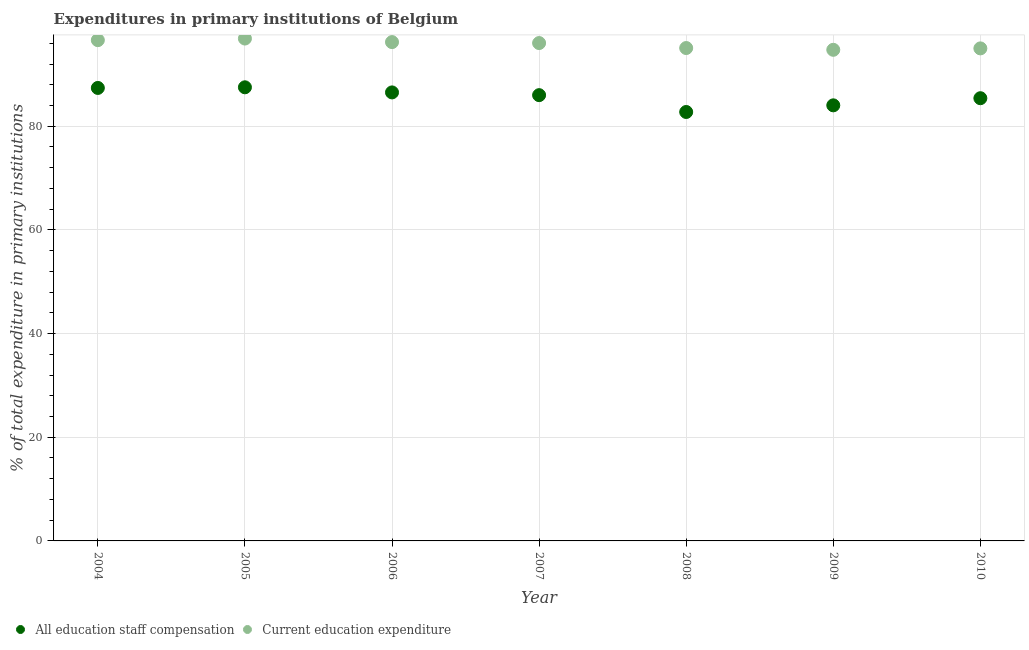How many different coloured dotlines are there?
Your response must be concise. 2. Is the number of dotlines equal to the number of legend labels?
Your response must be concise. Yes. What is the expenditure in education in 2009?
Give a very brief answer. 94.74. Across all years, what is the maximum expenditure in staff compensation?
Provide a short and direct response. 87.51. Across all years, what is the minimum expenditure in education?
Give a very brief answer. 94.74. In which year was the expenditure in staff compensation maximum?
Ensure brevity in your answer.  2005. What is the total expenditure in education in the graph?
Your answer should be very brief. 670.62. What is the difference between the expenditure in education in 2005 and that in 2007?
Provide a short and direct response. 0.87. What is the difference between the expenditure in staff compensation in 2004 and the expenditure in education in 2008?
Provide a succinct answer. -7.7. What is the average expenditure in education per year?
Your answer should be compact. 95.8. In the year 2008, what is the difference between the expenditure in staff compensation and expenditure in education?
Your answer should be very brief. -12.34. In how many years, is the expenditure in staff compensation greater than 84 %?
Make the answer very short. 6. What is the ratio of the expenditure in education in 2006 to that in 2007?
Your answer should be compact. 1. Is the expenditure in staff compensation in 2005 less than that in 2006?
Keep it short and to the point. No. Is the difference between the expenditure in education in 2006 and 2008 greater than the difference between the expenditure in staff compensation in 2006 and 2008?
Provide a succinct answer. No. What is the difference between the highest and the second highest expenditure in staff compensation?
Provide a short and direct response. 0.12. What is the difference between the highest and the lowest expenditure in education?
Ensure brevity in your answer.  2.17. In how many years, is the expenditure in education greater than the average expenditure in education taken over all years?
Provide a succinct answer. 4. Does the expenditure in staff compensation monotonically increase over the years?
Your answer should be very brief. No. Is the expenditure in staff compensation strictly greater than the expenditure in education over the years?
Make the answer very short. No. Are the values on the major ticks of Y-axis written in scientific E-notation?
Your answer should be compact. No. Does the graph contain grids?
Offer a terse response. Yes. Where does the legend appear in the graph?
Your answer should be compact. Bottom left. How many legend labels are there?
Provide a succinct answer. 2. How are the legend labels stacked?
Provide a short and direct response. Horizontal. What is the title of the graph?
Provide a succinct answer. Expenditures in primary institutions of Belgium. What is the label or title of the X-axis?
Provide a succinct answer. Year. What is the label or title of the Y-axis?
Give a very brief answer. % of total expenditure in primary institutions. What is the % of total expenditure in primary institutions of All education staff compensation in 2004?
Keep it short and to the point. 87.38. What is the % of total expenditure in primary institutions of Current education expenditure in 2004?
Your answer should be very brief. 96.6. What is the % of total expenditure in primary institutions in All education staff compensation in 2005?
Give a very brief answer. 87.51. What is the % of total expenditure in primary institutions in Current education expenditure in 2005?
Keep it short and to the point. 96.91. What is the % of total expenditure in primary institutions of All education staff compensation in 2006?
Keep it short and to the point. 86.52. What is the % of total expenditure in primary institutions in Current education expenditure in 2006?
Provide a succinct answer. 96.23. What is the % of total expenditure in primary institutions of All education staff compensation in 2007?
Provide a short and direct response. 85.99. What is the % of total expenditure in primary institutions in Current education expenditure in 2007?
Provide a succinct answer. 96.04. What is the % of total expenditure in primary institutions in All education staff compensation in 2008?
Keep it short and to the point. 82.74. What is the % of total expenditure in primary institutions of Current education expenditure in 2008?
Keep it short and to the point. 95.08. What is the % of total expenditure in primary institutions of All education staff compensation in 2009?
Offer a very short reply. 84.03. What is the % of total expenditure in primary institutions of Current education expenditure in 2009?
Your answer should be compact. 94.74. What is the % of total expenditure in primary institutions of All education staff compensation in 2010?
Give a very brief answer. 85.4. What is the % of total expenditure in primary institutions of Current education expenditure in 2010?
Make the answer very short. 95.01. Across all years, what is the maximum % of total expenditure in primary institutions of All education staff compensation?
Provide a succinct answer. 87.51. Across all years, what is the maximum % of total expenditure in primary institutions of Current education expenditure?
Provide a succinct answer. 96.91. Across all years, what is the minimum % of total expenditure in primary institutions of All education staff compensation?
Your answer should be very brief. 82.74. Across all years, what is the minimum % of total expenditure in primary institutions of Current education expenditure?
Your response must be concise. 94.74. What is the total % of total expenditure in primary institutions of All education staff compensation in the graph?
Provide a short and direct response. 599.58. What is the total % of total expenditure in primary institutions of Current education expenditure in the graph?
Your answer should be compact. 670.62. What is the difference between the % of total expenditure in primary institutions of All education staff compensation in 2004 and that in 2005?
Make the answer very short. -0.12. What is the difference between the % of total expenditure in primary institutions of Current education expenditure in 2004 and that in 2005?
Your answer should be very brief. -0.31. What is the difference between the % of total expenditure in primary institutions in All education staff compensation in 2004 and that in 2006?
Your answer should be very brief. 0.86. What is the difference between the % of total expenditure in primary institutions of Current education expenditure in 2004 and that in 2006?
Your response must be concise. 0.38. What is the difference between the % of total expenditure in primary institutions of All education staff compensation in 2004 and that in 2007?
Ensure brevity in your answer.  1.39. What is the difference between the % of total expenditure in primary institutions of Current education expenditure in 2004 and that in 2007?
Keep it short and to the point. 0.56. What is the difference between the % of total expenditure in primary institutions in All education staff compensation in 2004 and that in 2008?
Your answer should be very brief. 4.64. What is the difference between the % of total expenditure in primary institutions in Current education expenditure in 2004 and that in 2008?
Your response must be concise. 1.52. What is the difference between the % of total expenditure in primary institutions of All education staff compensation in 2004 and that in 2009?
Your response must be concise. 3.36. What is the difference between the % of total expenditure in primary institutions of Current education expenditure in 2004 and that in 2009?
Offer a terse response. 1.86. What is the difference between the % of total expenditure in primary institutions of All education staff compensation in 2004 and that in 2010?
Provide a succinct answer. 1.98. What is the difference between the % of total expenditure in primary institutions of Current education expenditure in 2004 and that in 2010?
Make the answer very short. 1.59. What is the difference between the % of total expenditure in primary institutions of All education staff compensation in 2005 and that in 2006?
Give a very brief answer. 0.99. What is the difference between the % of total expenditure in primary institutions of Current education expenditure in 2005 and that in 2006?
Your answer should be compact. 0.68. What is the difference between the % of total expenditure in primary institutions in All education staff compensation in 2005 and that in 2007?
Make the answer very short. 1.51. What is the difference between the % of total expenditure in primary institutions of Current education expenditure in 2005 and that in 2007?
Your response must be concise. 0.87. What is the difference between the % of total expenditure in primary institutions in All education staff compensation in 2005 and that in 2008?
Keep it short and to the point. 4.76. What is the difference between the % of total expenditure in primary institutions in Current education expenditure in 2005 and that in 2008?
Offer a very short reply. 1.83. What is the difference between the % of total expenditure in primary institutions in All education staff compensation in 2005 and that in 2009?
Make the answer very short. 3.48. What is the difference between the % of total expenditure in primary institutions in Current education expenditure in 2005 and that in 2009?
Provide a succinct answer. 2.17. What is the difference between the % of total expenditure in primary institutions of All education staff compensation in 2005 and that in 2010?
Offer a very short reply. 2.1. What is the difference between the % of total expenditure in primary institutions of Current education expenditure in 2005 and that in 2010?
Ensure brevity in your answer.  1.9. What is the difference between the % of total expenditure in primary institutions in All education staff compensation in 2006 and that in 2007?
Your answer should be very brief. 0.53. What is the difference between the % of total expenditure in primary institutions in Current education expenditure in 2006 and that in 2007?
Provide a succinct answer. 0.19. What is the difference between the % of total expenditure in primary institutions of All education staff compensation in 2006 and that in 2008?
Your answer should be very brief. 3.78. What is the difference between the % of total expenditure in primary institutions of Current education expenditure in 2006 and that in 2008?
Make the answer very short. 1.15. What is the difference between the % of total expenditure in primary institutions of All education staff compensation in 2006 and that in 2009?
Your answer should be very brief. 2.5. What is the difference between the % of total expenditure in primary institutions of Current education expenditure in 2006 and that in 2009?
Provide a short and direct response. 1.49. What is the difference between the % of total expenditure in primary institutions of All education staff compensation in 2006 and that in 2010?
Offer a very short reply. 1.12. What is the difference between the % of total expenditure in primary institutions in Current education expenditure in 2006 and that in 2010?
Keep it short and to the point. 1.21. What is the difference between the % of total expenditure in primary institutions of All education staff compensation in 2007 and that in 2008?
Keep it short and to the point. 3.25. What is the difference between the % of total expenditure in primary institutions of Current education expenditure in 2007 and that in 2008?
Your answer should be compact. 0.96. What is the difference between the % of total expenditure in primary institutions of All education staff compensation in 2007 and that in 2009?
Your answer should be compact. 1.97. What is the difference between the % of total expenditure in primary institutions of Current education expenditure in 2007 and that in 2009?
Give a very brief answer. 1.3. What is the difference between the % of total expenditure in primary institutions in All education staff compensation in 2007 and that in 2010?
Provide a short and direct response. 0.59. What is the difference between the % of total expenditure in primary institutions of Current education expenditure in 2007 and that in 2010?
Ensure brevity in your answer.  1.03. What is the difference between the % of total expenditure in primary institutions of All education staff compensation in 2008 and that in 2009?
Ensure brevity in your answer.  -1.28. What is the difference between the % of total expenditure in primary institutions in Current education expenditure in 2008 and that in 2009?
Your answer should be compact. 0.34. What is the difference between the % of total expenditure in primary institutions in All education staff compensation in 2008 and that in 2010?
Give a very brief answer. -2.66. What is the difference between the % of total expenditure in primary institutions of Current education expenditure in 2008 and that in 2010?
Give a very brief answer. 0.07. What is the difference between the % of total expenditure in primary institutions in All education staff compensation in 2009 and that in 2010?
Your answer should be very brief. -1.38. What is the difference between the % of total expenditure in primary institutions in Current education expenditure in 2009 and that in 2010?
Provide a short and direct response. -0.27. What is the difference between the % of total expenditure in primary institutions in All education staff compensation in 2004 and the % of total expenditure in primary institutions in Current education expenditure in 2005?
Ensure brevity in your answer.  -9.53. What is the difference between the % of total expenditure in primary institutions of All education staff compensation in 2004 and the % of total expenditure in primary institutions of Current education expenditure in 2006?
Your answer should be compact. -8.84. What is the difference between the % of total expenditure in primary institutions in All education staff compensation in 2004 and the % of total expenditure in primary institutions in Current education expenditure in 2007?
Your answer should be very brief. -8.66. What is the difference between the % of total expenditure in primary institutions in All education staff compensation in 2004 and the % of total expenditure in primary institutions in Current education expenditure in 2008?
Give a very brief answer. -7.7. What is the difference between the % of total expenditure in primary institutions of All education staff compensation in 2004 and the % of total expenditure in primary institutions of Current education expenditure in 2009?
Provide a short and direct response. -7.36. What is the difference between the % of total expenditure in primary institutions of All education staff compensation in 2004 and the % of total expenditure in primary institutions of Current education expenditure in 2010?
Your response must be concise. -7.63. What is the difference between the % of total expenditure in primary institutions in All education staff compensation in 2005 and the % of total expenditure in primary institutions in Current education expenditure in 2006?
Provide a succinct answer. -8.72. What is the difference between the % of total expenditure in primary institutions of All education staff compensation in 2005 and the % of total expenditure in primary institutions of Current education expenditure in 2007?
Offer a terse response. -8.53. What is the difference between the % of total expenditure in primary institutions in All education staff compensation in 2005 and the % of total expenditure in primary institutions in Current education expenditure in 2008?
Your response must be concise. -7.57. What is the difference between the % of total expenditure in primary institutions of All education staff compensation in 2005 and the % of total expenditure in primary institutions of Current education expenditure in 2009?
Make the answer very short. -7.23. What is the difference between the % of total expenditure in primary institutions of All education staff compensation in 2005 and the % of total expenditure in primary institutions of Current education expenditure in 2010?
Keep it short and to the point. -7.51. What is the difference between the % of total expenditure in primary institutions of All education staff compensation in 2006 and the % of total expenditure in primary institutions of Current education expenditure in 2007?
Ensure brevity in your answer.  -9.52. What is the difference between the % of total expenditure in primary institutions of All education staff compensation in 2006 and the % of total expenditure in primary institutions of Current education expenditure in 2008?
Offer a very short reply. -8.56. What is the difference between the % of total expenditure in primary institutions in All education staff compensation in 2006 and the % of total expenditure in primary institutions in Current education expenditure in 2009?
Your answer should be very brief. -8.22. What is the difference between the % of total expenditure in primary institutions of All education staff compensation in 2006 and the % of total expenditure in primary institutions of Current education expenditure in 2010?
Ensure brevity in your answer.  -8.49. What is the difference between the % of total expenditure in primary institutions in All education staff compensation in 2007 and the % of total expenditure in primary institutions in Current education expenditure in 2008?
Your response must be concise. -9.09. What is the difference between the % of total expenditure in primary institutions in All education staff compensation in 2007 and the % of total expenditure in primary institutions in Current education expenditure in 2009?
Ensure brevity in your answer.  -8.75. What is the difference between the % of total expenditure in primary institutions in All education staff compensation in 2007 and the % of total expenditure in primary institutions in Current education expenditure in 2010?
Offer a very short reply. -9.02. What is the difference between the % of total expenditure in primary institutions of All education staff compensation in 2008 and the % of total expenditure in primary institutions of Current education expenditure in 2009?
Provide a succinct answer. -11.99. What is the difference between the % of total expenditure in primary institutions of All education staff compensation in 2008 and the % of total expenditure in primary institutions of Current education expenditure in 2010?
Keep it short and to the point. -12.27. What is the difference between the % of total expenditure in primary institutions in All education staff compensation in 2009 and the % of total expenditure in primary institutions in Current education expenditure in 2010?
Provide a short and direct response. -10.99. What is the average % of total expenditure in primary institutions of All education staff compensation per year?
Offer a very short reply. 85.65. What is the average % of total expenditure in primary institutions in Current education expenditure per year?
Your answer should be compact. 95.8. In the year 2004, what is the difference between the % of total expenditure in primary institutions of All education staff compensation and % of total expenditure in primary institutions of Current education expenditure?
Provide a short and direct response. -9.22. In the year 2005, what is the difference between the % of total expenditure in primary institutions in All education staff compensation and % of total expenditure in primary institutions in Current education expenditure?
Ensure brevity in your answer.  -9.4. In the year 2006, what is the difference between the % of total expenditure in primary institutions of All education staff compensation and % of total expenditure in primary institutions of Current education expenditure?
Offer a terse response. -9.71. In the year 2007, what is the difference between the % of total expenditure in primary institutions in All education staff compensation and % of total expenditure in primary institutions in Current education expenditure?
Provide a succinct answer. -10.05. In the year 2008, what is the difference between the % of total expenditure in primary institutions of All education staff compensation and % of total expenditure in primary institutions of Current education expenditure?
Provide a short and direct response. -12.34. In the year 2009, what is the difference between the % of total expenditure in primary institutions of All education staff compensation and % of total expenditure in primary institutions of Current education expenditure?
Provide a succinct answer. -10.71. In the year 2010, what is the difference between the % of total expenditure in primary institutions of All education staff compensation and % of total expenditure in primary institutions of Current education expenditure?
Ensure brevity in your answer.  -9.61. What is the ratio of the % of total expenditure in primary institutions of All education staff compensation in 2004 to that in 2005?
Offer a terse response. 1. What is the ratio of the % of total expenditure in primary institutions in All education staff compensation in 2004 to that in 2006?
Your answer should be compact. 1.01. What is the ratio of the % of total expenditure in primary institutions of Current education expenditure in 2004 to that in 2006?
Offer a very short reply. 1. What is the ratio of the % of total expenditure in primary institutions in All education staff compensation in 2004 to that in 2007?
Your answer should be very brief. 1.02. What is the ratio of the % of total expenditure in primary institutions in Current education expenditure in 2004 to that in 2007?
Your answer should be compact. 1.01. What is the ratio of the % of total expenditure in primary institutions of All education staff compensation in 2004 to that in 2008?
Keep it short and to the point. 1.06. What is the ratio of the % of total expenditure in primary institutions in Current education expenditure in 2004 to that in 2008?
Make the answer very short. 1.02. What is the ratio of the % of total expenditure in primary institutions in All education staff compensation in 2004 to that in 2009?
Keep it short and to the point. 1.04. What is the ratio of the % of total expenditure in primary institutions in Current education expenditure in 2004 to that in 2009?
Make the answer very short. 1.02. What is the ratio of the % of total expenditure in primary institutions in All education staff compensation in 2004 to that in 2010?
Ensure brevity in your answer.  1.02. What is the ratio of the % of total expenditure in primary institutions in Current education expenditure in 2004 to that in 2010?
Give a very brief answer. 1.02. What is the ratio of the % of total expenditure in primary institutions of All education staff compensation in 2005 to that in 2006?
Your answer should be very brief. 1.01. What is the ratio of the % of total expenditure in primary institutions of Current education expenditure in 2005 to that in 2006?
Provide a succinct answer. 1.01. What is the ratio of the % of total expenditure in primary institutions of All education staff compensation in 2005 to that in 2007?
Give a very brief answer. 1.02. What is the ratio of the % of total expenditure in primary institutions of Current education expenditure in 2005 to that in 2007?
Offer a very short reply. 1.01. What is the ratio of the % of total expenditure in primary institutions of All education staff compensation in 2005 to that in 2008?
Your response must be concise. 1.06. What is the ratio of the % of total expenditure in primary institutions of Current education expenditure in 2005 to that in 2008?
Provide a short and direct response. 1.02. What is the ratio of the % of total expenditure in primary institutions in All education staff compensation in 2005 to that in 2009?
Keep it short and to the point. 1.04. What is the ratio of the % of total expenditure in primary institutions in Current education expenditure in 2005 to that in 2009?
Keep it short and to the point. 1.02. What is the ratio of the % of total expenditure in primary institutions of All education staff compensation in 2005 to that in 2010?
Provide a succinct answer. 1.02. What is the ratio of the % of total expenditure in primary institutions in All education staff compensation in 2006 to that in 2008?
Offer a very short reply. 1.05. What is the ratio of the % of total expenditure in primary institutions of All education staff compensation in 2006 to that in 2009?
Your response must be concise. 1.03. What is the ratio of the % of total expenditure in primary institutions of Current education expenditure in 2006 to that in 2009?
Offer a very short reply. 1.02. What is the ratio of the % of total expenditure in primary institutions of All education staff compensation in 2006 to that in 2010?
Your answer should be compact. 1.01. What is the ratio of the % of total expenditure in primary institutions of Current education expenditure in 2006 to that in 2010?
Ensure brevity in your answer.  1.01. What is the ratio of the % of total expenditure in primary institutions in All education staff compensation in 2007 to that in 2008?
Make the answer very short. 1.04. What is the ratio of the % of total expenditure in primary institutions in All education staff compensation in 2007 to that in 2009?
Your answer should be compact. 1.02. What is the ratio of the % of total expenditure in primary institutions in Current education expenditure in 2007 to that in 2009?
Give a very brief answer. 1.01. What is the ratio of the % of total expenditure in primary institutions in Current education expenditure in 2007 to that in 2010?
Give a very brief answer. 1.01. What is the ratio of the % of total expenditure in primary institutions in All education staff compensation in 2008 to that in 2009?
Keep it short and to the point. 0.98. What is the ratio of the % of total expenditure in primary institutions of All education staff compensation in 2008 to that in 2010?
Make the answer very short. 0.97. What is the ratio of the % of total expenditure in primary institutions of All education staff compensation in 2009 to that in 2010?
Offer a terse response. 0.98. What is the difference between the highest and the second highest % of total expenditure in primary institutions in All education staff compensation?
Make the answer very short. 0.12. What is the difference between the highest and the second highest % of total expenditure in primary institutions in Current education expenditure?
Your response must be concise. 0.31. What is the difference between the highest and the lowest % of total expenditure in primary institutions of All education staff compensation?
Give a very brief answer. 4.76. What is the difference between the highest and the lowest % of total expenditure in primary institutions in Current education expenditure?
Give a very brief answer. 2.17. 